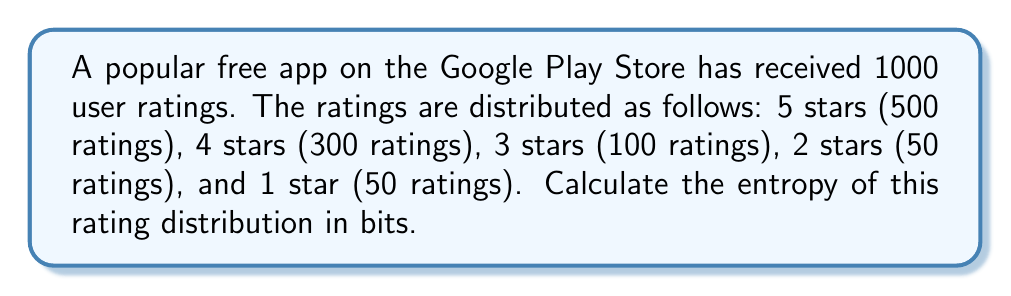Give your solution to this math problem. To calculate the entropy of the rating distribution, we'll use the Shannon entropy formula:

$$S = -\sum_{i=1}^n p_i \log_2(p_i)$$

Where $p_i$ is the probability of each rating.

Step 1: Calculate the probabilities for each rating:
$p_5 = 500/1000 = 0.5$
$p_4 = 300/1000 = 0.3$
$p_3 = 100/1000 = 0.1$
$p_2 = 50/1000 = 0.05$
$p_1 = 50/1000 = 0.05$

Step 2: Calculate each term of the sum:
$-0.5 \log_2(0.5) = 0.5$
$-0.3 \log_2(0.3) \approx 0.5211$
$-0.1 \log_2(0.1) \approx 0.3322$
$-0.05 \log_2(0.05) \approx 0.2161$
$-0.05 \log_2(0.05) \approx 0.2161$

Step 3: Sum all terms:
$S = 0.5 + 0.5211 + 0.3322 + 0.2161 + 0.2161 = 1.7855$ bits
Answer: 1.7855 bits 